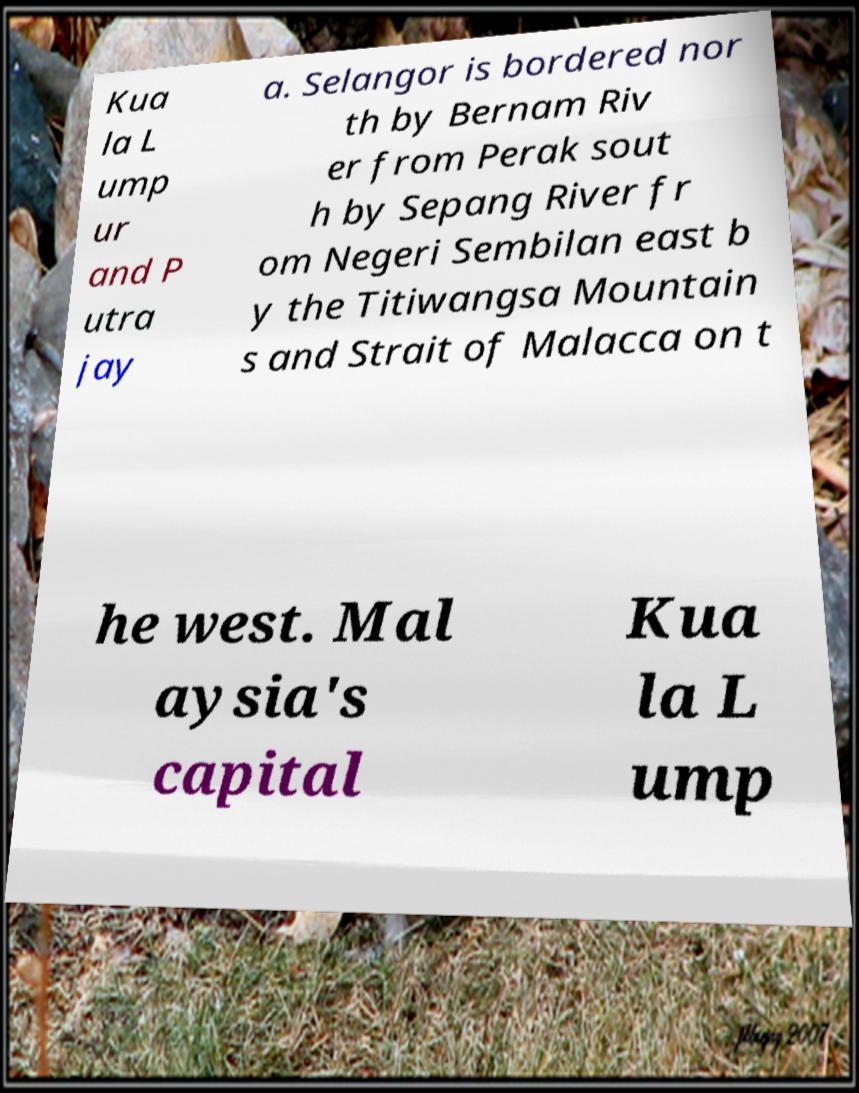Could you assist in decoding the text presented in this image and type it out clearly? Kua la L ump ur and P utra jay a. Selangor is bordered nor th by Bernam Riv er from Perak sout h by Sepang River fr om Negeri Sembilan east b y the Titiwangsa Mountain s and Strait of Malacca on t he west. Mal aysia's capital Kua la L ump 